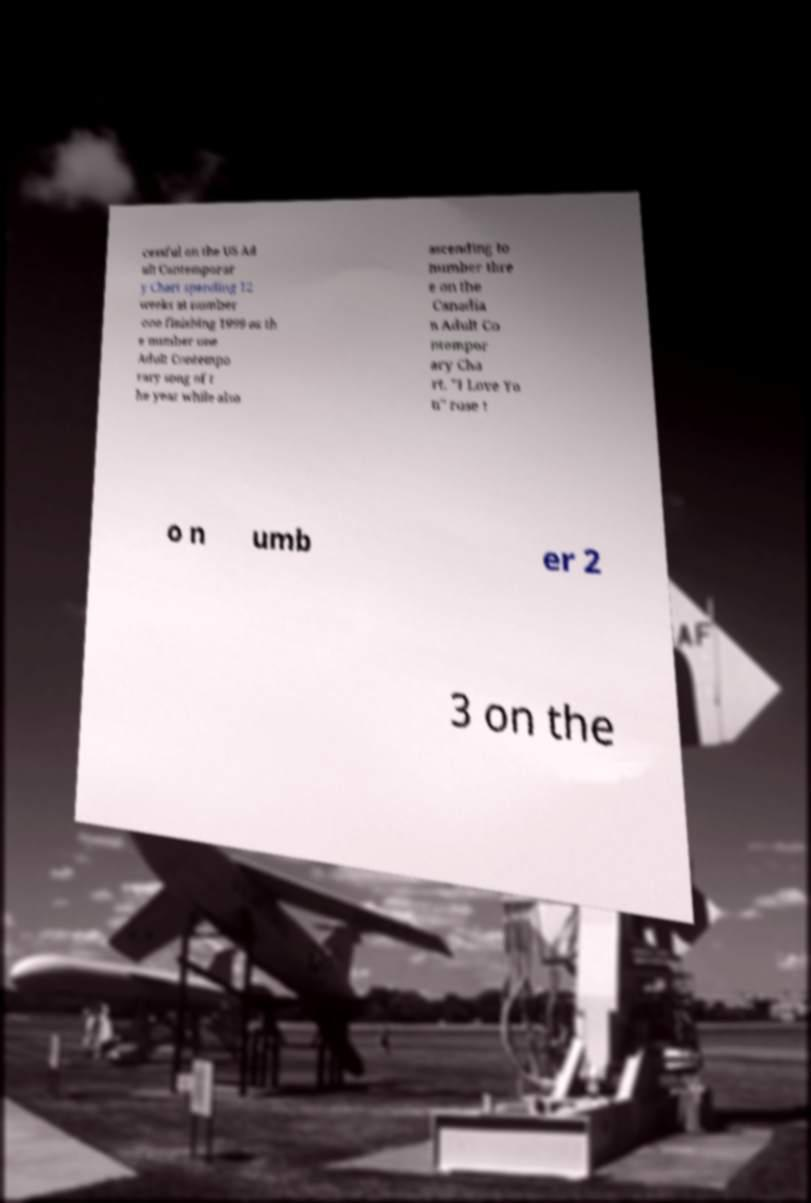Could you extract and type out the text from this image? cessful on the US Ad ult Contemporar y Chart spending 12 weeks at number one finishing 1999 as th e number one Adult Contempo rary song of t he year while also ascending to number thre e on the Canadia n Adult Co ntempor ary Cha rt. "I Love Yo u" rose t o n umb er 2 3 on the 